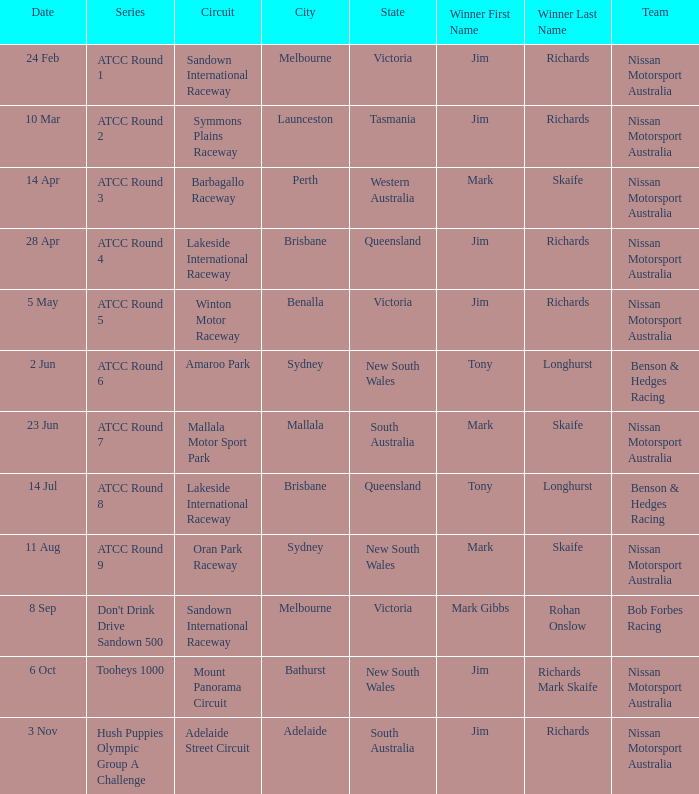What is the Team of Winner Mark Skaife in ATCC Round 7? Nissan Motorsport Australia. 